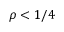Convert formula to latex. <formula><loc_0><loc_0><loc_500><loc_500>\rho < 1 / 4</formula> 